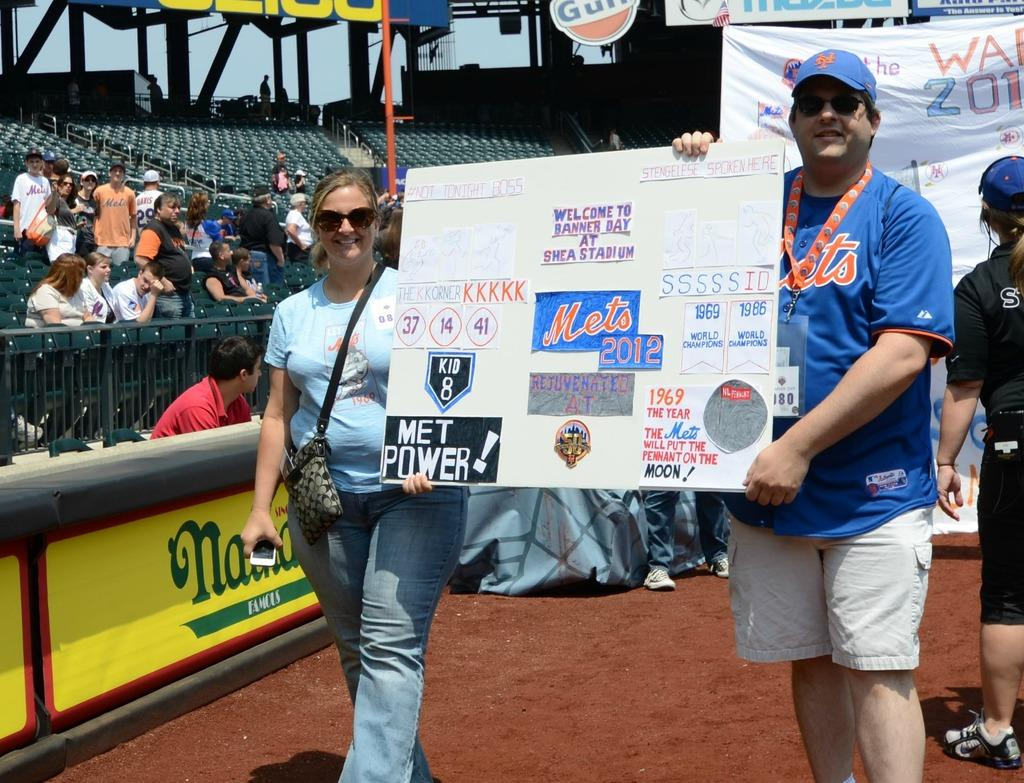<image>
Render a clear and concise summary of the photo. A man and woman holding a sign that says "Welcome to Banner Day at Shea Stadium" 